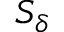<formula> <loc_0><loc_0><loc_500><loc_500>S _ { \delta }</formula> 